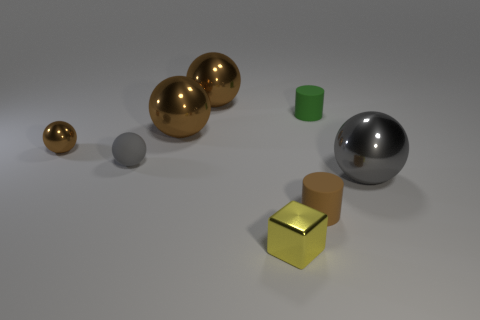Subtract all purple blocks. How many brown spheres are left? 3 Subtract all cyan cylinders. Subtract all gray blocks. How many cylinders are left? 2 Subtract all cylinders. How many objects are left? 6 Subtract all large brown metallic objects. Subtract all tiny brown cylinders. How many objects are left? 5 Add 1 gray rubber objects. How many gray rubber objects are left? 2 Add 5 big metallic blocks. How many big metallic blocks exist? 5 Subtract 0 gray cylinders. How many objects are left? 8 